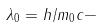<formula> <loc_0><loc_0><loc_500><loc_500>\lambda _ { 0 } = h / m _ { 0 } c -</formula> 